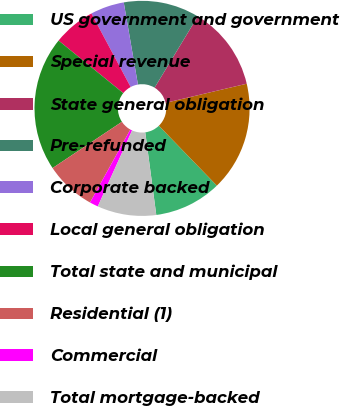Convert chart to OTSL. <chart><loc_0><loc_0><loc_500><loc_500><pie_chart><fcel>US government and government<fcel>Special revenue<fcel>State general obligation<fcel>Pre-refunded<fcel>Corporate backed<fcel>Local general obligation<fcel>Total state and municipal<fcel>Residential (1)<fcel>Commercial<fcel>Total mortgage-backed<nl><fcel>10.13%<fcel>16.44%<fcel>12.65%<fcel>11.39%<fcel>5.08%<fcel>6.34%<fcel>20.22%<fcel>7.6%<fcel>1.29%<fcel>8.86%<nl></chart> 